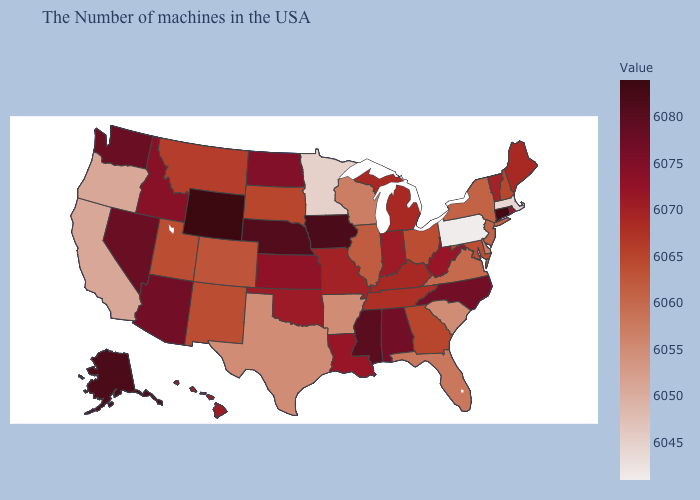Does Connecticut have the highest value in the Northeast?
Quick response, please. Yes. Does the map have missing data?
Be succinct. No. Among the states that border Arizona , which have the lowest value?
Short answer required. California. Does Georgia have the highest value in the USA?
Answer briefly. No. Is the legend a continuous bar?
Quick response, please. Yes. 